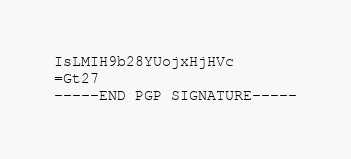Convert code to text. <code><loc_0><loc_0><loc_500><loc_500><_SML_>IsLMIH9b28YUojxHjHVc
=Gt27
-----END PGP SIGNATURE-----
</code> 